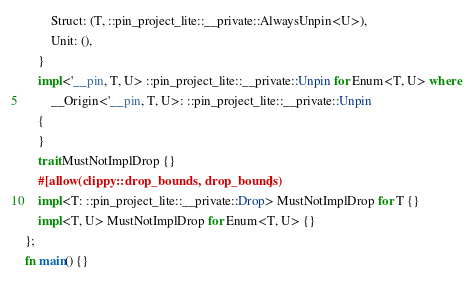<code> <loc_0><loc_0><loc_500><loc_500><_Rust_>        Struct: (T, ::pin_project_lite::__private::AlwaysUnpin<U>),
        Unit: (),
    }
    impl<'__pin, T, U> ::pin_project_lite::__private::Unpin for Enum<T, U> where
        __Origin<'__pin, T, U>: ::pin_project_lite::__private::Unpin
    {
    }
    trait MustNotImplDrop {}
    #[allow(clippy::drop_bounds, drop_bounds)]
    impl<T: ::pin_project_lite::__private::Drop> MustNotImplDrop for T {}
    impl<T, U> MustNotImplDrop for Enum<T, U> {}
};
fn main() {}
</code> 